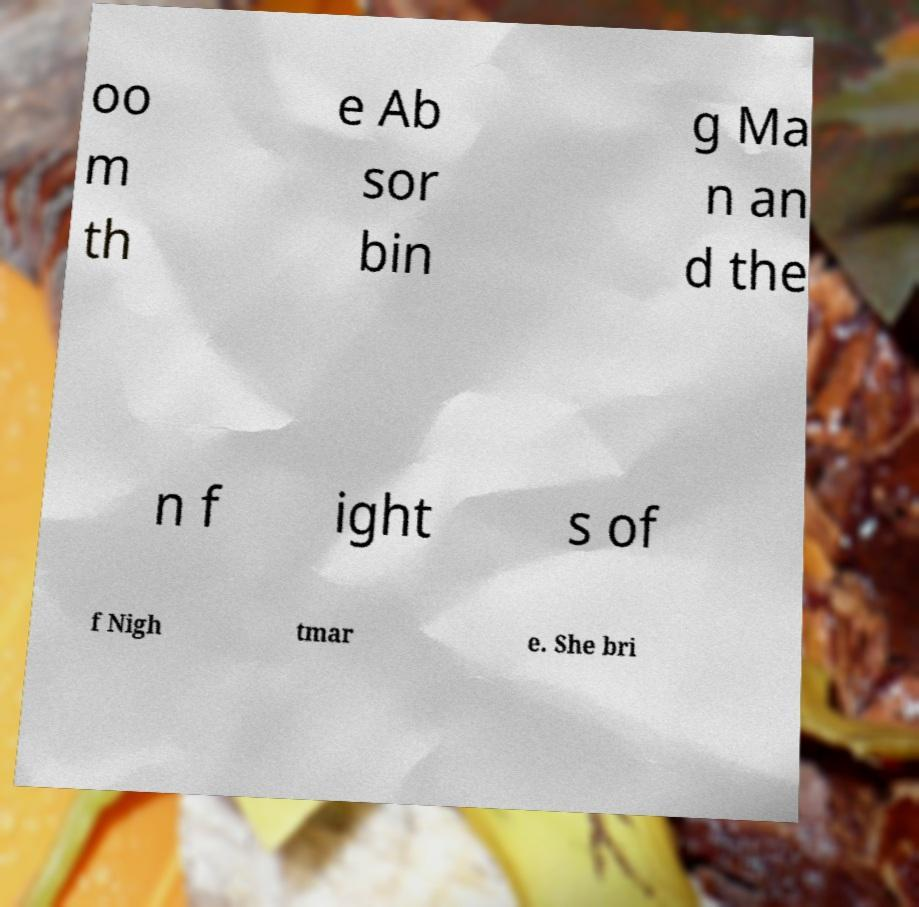There's text embedded in this image that I need extracted. Can you transcribe it verbatim? oo m th e Ab sor bin g Ma n an d the n f ight s of f Nigh tmar e. She bri 